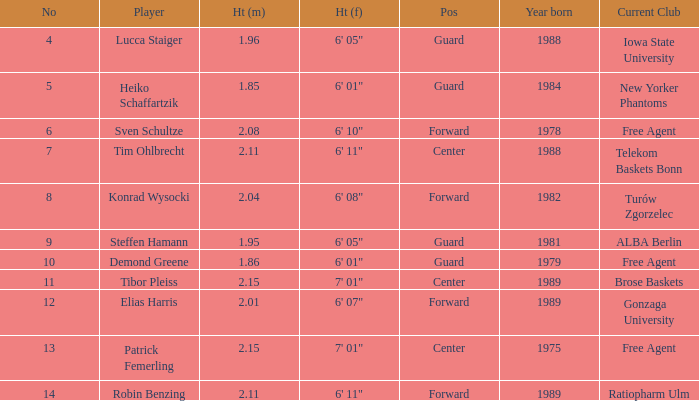Identify the height of the athlete born in 1989 and has a height of 2.11 meters. 6' 11". 